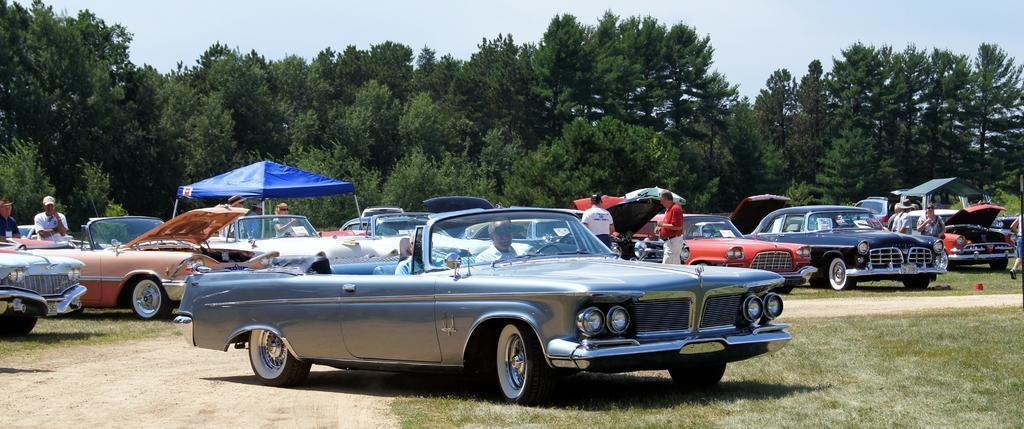Could you give a brief overview of what you see in this image? In the foreground of the image we can see cars and some persons. In the middle of the image we can see trees. On the top of the image we can see the sky. 